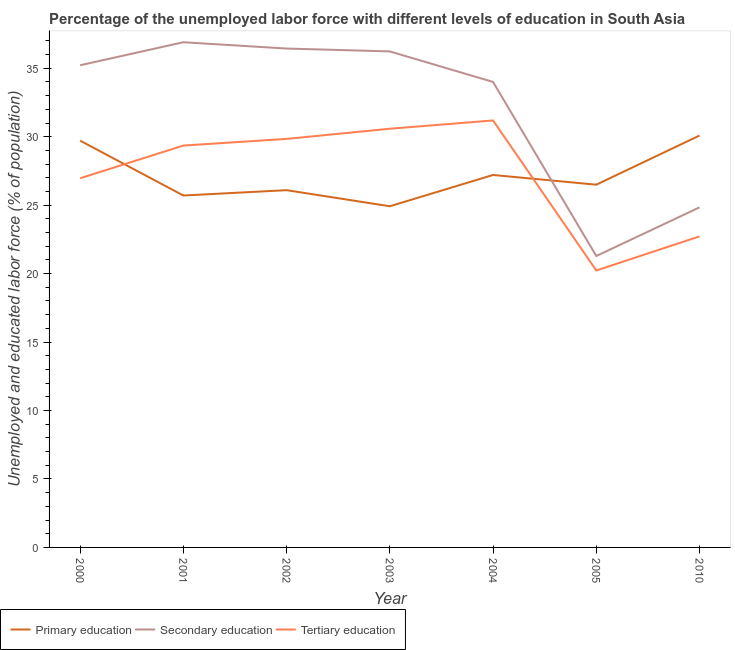How many different coloured lines are there?
Ensure brevity in your answer.  3. Does the line corresponding to percentage of labor force who received tertiary education intersect with the line corresponding to percentage of labor force who received secondary education?
Provide a succinct answer. No. Is the number of lines equal to the number of legend labels?
Your answer should be very brief. Yes. What is the percentage of labor force who received tertiary education in 2004?
Offer a very short reply. 31.19. Across all years, what is the maximum percentage of labor force who received primary education?
Your answer should be very brief. 30.08. Across all years, what is the minimum percentage of labor force who received tertiary education?
Your answer should be compact. 20.23. What is the total percentage of labor force who received secondary education in the graph?
Your answer should be very brief. 224.9. What is the difference between the percentage of labor force who received secondary education in 2000 and that in 2002?
Your response must be concise. -1.22. What is the difference between the percentage of labor force who received primary education in 2004 and the percentage of labor force who received tertiary education in 2001?
Ensure brevity in your answer.  -2.15. What is the average percentage of labor force who received primary education per year?
Offer a terse response. 27.17. In the year 2005, what is the difference between the percentage of labor force who received secondary education and percentage of labor force who received primary education?
Offer a very short reply. -5.21. In how many years, is the percentage of labor force who received primary education greater than 15 %?
Provide a short and direct response. 7. What is the ratio of the percentage of labor force who received secondary education in 2003 to that in 2005?
Offer a terse response. 1.7. What is the difference between the highest and the second highest percentage of labor force who received secondary education?
Make the answer very short. 0.46. What is the difference between the highest and the lowest percentage of labor force who received tertiary education?
Keep it short and to the point. 10.96. Is the sum of the percentage of labor force who received primary education in 2000 and 2010 greater than the maximum percentage of labor force who received secondary education across all years?
Provide a succinct answer. Yes. Is it the case that in every year, the sum of the percentage of labor force who received primary education and percentage of labor force who received secondary education is greater than the percentage of labor force who received tertiary education?
Give a very brief answer. Yes. How many lines are there?
Provide a succinct answer. 3. How many years are there in the graph?
Your answer should be compact. 7. Are the values on the major ticks of Y-axis written in scientific E-notation?
Your response must be concise. No. Does the graph contain any zero values?
Offer a terse response. No. Does the graph contain grids?
Your answer should be compact. No. Where does the legend appear in the graph?
Ensure brevity in your answer.  Bottom left. What is the title of the graph?
Keep it short and to the point. Percentage of the unemployed labor force with different levels of education in South Asia. Does "Male employers" appear as one of the legend labels in the graph?
Your answer should be very brief. No. What is the label or title of the X-axis?
Your response must be concise. Year. What is the label or title of the Y-axis?
Your answer should be compact. Unemployed and educated labor force (% of population). What is the Unemployed and educated labor force (% of population) in Primary education in 2000?
Give a very brief answer. 29.71. What is the Unemployed and educated labor force (% of population) in Secondary education in 2000?
Provide a short and direct response. 35.22. What is the Unemployed and educated labor force (% of population) in Tertiary education in 2000?
Your answer should be very brief. 26.96. What is the Unemployed and educated labor force (% of population) of Primary education in 2001?
Your answer should be compact. 25.7. What is the Unemployed and educated labor force (% of population) in Secondary education in 2001?
Offer a terse response. 36.9. What is the Unemployed and educated labor force (% of population) of Tertiary education in 2001?
Make the answer very short. 29.35. What is the Unemployed and educated labor force (% of population) in Primary education in 2002?
Provide a succinct answer. 26.09. What is the Unemployed and educated labor force (% of population) in Secondary education in 2002?
Keep it short and to the point. 36.44. What is the Unemployed and educated labor force (% of population) in Tertiary education in 2002?
Your answer should be compact. 29.84. What is the Unemployed and educated labor force (% of population) in Primary education in 2003?
Your answer should be very brief. 24.92. What is the Unemployed and educated labor force (% of population) of Secondary education in 2003?
Offer a terse response. 36.23. What is the Unemployed and educated labor force (% of population) in Tertiary education in 2003?
Provide a short and direct response. 30.58. What is the Unemployed and educated labor force (% of population) in Primary education in 2004?
Your answer should be very brief. 27.2. What is the Unemployed and educated labor force (% of population) of Secondary education in 2004?
Make the answer very short. 34. What is the Unemployed and educated labor force (% of population) of Tertiary education in 2004?
Offer a terse response. 31.19. What is the Unemployed and educated labor force (% of population) of Primary education in 2005?
Your response must be concise. 26.5. What is the Unemployed and educated labor force (% of population) of Secondary education in 2005?
Give a very brief answer. 21.28. What is the Unemployed and educated labor force (% of population) of Tertiary education in 2005?
Make the answer very short. 20.23. What is the Unemployed and educated labor force (% of population) in Primary education in 2010?
Provide a short and direct response. 30.08. What is the Unemployed and educated labor force (% of population) of Secondary education in 2010?
Provide a short and direct response. 24.84. What is the Unemployed and educated labor force (% of population) of Tertiary education in 2010?
Your answer should be very brief. 22.72. Across all years, what is the maximum Unemployed and educated labor force (% of population) of Primary education?
Keep it short and to the point. 30.08. Across all years, what is the maximum Unemployed and educated labor force (% of population) in Secondary education?
Give a very brief answer. 36.9. Across all years, what is the maximum Unemployed and educated labor force (% of population) of Tertiary education?
Your response must be concise. 31.19. Across all years, what is the minimum Unemployed and educated labor force (% of population) in Primary education?
Ensure brevity in your answer.  24.92. Across all years, what is the minimum Unemployed and educated labor force (% of population) in Secondary education?
Offer a terse response. 21.28. Across all years, what is the minimum Unemployed and educated labor force (% of population) of Tertiary education?
Give a very brief answer. 20.23. What is the total Unemployed and educated labor force (% of population) in Primary education in the graph?
Offer a very short reply. 190.21. What is the total Unemployed and educated labor force (% of population) in Secondary education in the graph?
Your answer should be compact. 224.9. What is the total Unemployed and educated labor force (% of population) in Tertiary education in the graph?
Provide a succinct answer. 190.87. What is the difference between the Unemployed and educated labor force (% of population) in Primary education in 2000 and that in 2001?
Provide a short and direct response. 4.01. What is the difference between the Unemployed and educated labor force (% of population) of Secondary education in 2000 and that in 2001?
Your answer should be compact. -1.68. What is the difference between the Unemployed and educated labor force (% of population) of Tertiary education in 2000 and that in 2001?
Your response must be concise. -2.39. What is the difference between the Unemployed and educated labor force (% of population) of Primary education in 2000 and that in 2002?
Ensure brevity in your answer.  3.62. What is the difference between the Unemployed and educated labor force (% of population) of Secondary education in 2000 and that in 2002?
Give a very brief answer. -1.22. What is the difference between the Unemployed and educated labor force (% of population) in Tertiary education in 2000 and that in 2002?
Your answer should be very brief. -2.88. What is the difference between the Unemployed and educated labor force (% of population) in Primary education in 2000 and that in 2003?
Offer a terse response. 4.79. What is the difference between the Unemployed and educated labor force (% of population) of Secondary education in 2000 and that in 2003?
Give a very brief answer. -1.01. What is the difference between the Unemployed and educated labor force (% of population) in Tertiary education in 2000 and that in 2003?
Offer a terse response. -3.62. What is the difference between the Unemployed and educated labor force (% of population) in Primary education in 2000 and that in 2004?
Your answer should be compact. 2.51. What is the difference between the Unemployed and educated labor force (% of population) in Secondary education in 2000 and that in 2004?
Keep it short and to the point. 1.22. What is the difference between the Unemployed and educated labor force (% of population) of Tertiary education in 2000 and that in 2004?
Offer a terse response. -4.22. What is the difference between the Unemployed and educated labor force (% of population) in Primary education in 2000 and that in 2005?
Give a very brief answer. 3.22. What is the difference between the Unemployed and educated labor force (% of population) of Secondary education in 2000 and that in 2005?
Make the answer very short. 13.93. What is the difference between the Unemployed and educated labor force (% of population) in Tertiary education in 2000 and that in 2005?
Keep it short and to the point. 6.74. What is the difference between the Unemployed and educated labor force (% of population) in Primary education in 2000 and that in 2010?
Your response must be concise. -0.37. What is the difference between the Unemployed and educated labor force (% of population) of Secondary education in 2000 and that in 2010?
Keep it short and to the point. 10.38. What is the difference between the Unemployed and educated labor force (% of population) in Tertiary education in 2000 and that in 2010?
Your answer should be very brief. 4.24. What is the difference between the Unemployed and educated labor force (% of population) of Primary education in 2001 and that in 2002?
Offer a very short reply. -0.39. What is the difference between the Unemployed and educated labor force (% of population) in Secondary education in 2001 and that in 2002?
Make the answer very short. 0.46. What is the difference between the Unemployed and educated labor force (% of population) in Tertiary education in 2001 and that in 2002?
Provide a short and direct response. -0.49. What is the difference between the Unemployed and educated labor force (% of population) in Primary education in 2001 and that in 2003?
Offer a very short reply. 0.78. What is the difference between the Unemployed and educated labor force (% of population) of Secondary education in 2001 and that in 2003?
Provide a short and direct response. 0.67. What is the difference between the Unemployed and educated labor force (% of population) in Tertiary education in 2001 and that in 2003?
Provide a succinct answer. -1.23. What is the difference between the Unemployed and educated labor force (% of population) in Primary education in 2001 and that in 2004?
Give a very brief answer. -1.5. What is the difference between the Unemployed and educated labor force (% of population) in Secondary education in 2001 and that in 2004?
Your answer should be compact. 2.9. What is the difference between the Unemployed and educated labor force (% of population) of Tertiary education in 2001 and that in 2004?
Provide a short and direct response. -1.83. What is the difference between the Unemployed and educated labor force (% of population) of Primary education in 2001 and that in 2005?
Keep it short and to the point. -0.79. What is the difference between the Unemployed and educated labor force (% of population) in Secondary education in 2001 and that in 2005?
Provide a succinct answer. 15.61. What is the difference between the Unemployed and educated labor force (% of population) in Tertiary education in 2001 and that in 2005?
Provide a succinct answer. 9.12. What is the difference between the Unemployed and educated labor force (% of population) in Primary education in 2001 and that in 2010?
Provide a short and direct response. -4.38. What is the difference between the Unemployed and educated labor force (% of population) in Secondary education in 2001 and that in 2010?
Provide a short and direct response. 12.06. What is the difference between the Unemployed and educated labor force (% of population) in Tertiary education in 2001 and that in 2010?
Ensure brevity in your answer.  6.63. What is the difference between the Unemployed and educated labor force (% of population) of Primary education in 2002 and that in 2003?
Provide a short and direct response. 1.17. What is the difference between the Unemployed and educated labor force (% of population) in Secondary education in 2002 and that in 2003?
Offer a terse response. 0.21. What is the difference between the Unemployed and educated labor force (% of population) of Tertiary education in 2002 and that in 2003?
Offer a terse response. -0.74. What is the difference between the Unemployed and educated labor force (% of population) of Primary education in 2002 and that in 2004?
Offer a terse response. -1.11. What is the difference between the Unemployed and educated labor force (% of population) of Secondary education in 2002 and that in 2004?
Provide a succinct answer. 2.44. What is the difference between the Unemployed and educated labor force (% of population) in Tertiary education in 2002 and that in 2004?
Provide a short and direct response. -1.35. What is the difference between the Unemployed and educated labor force (% of population) in Primary education in 2002 and that in 2005?
Provide a short and direct response. -0.4. What is the difference between the Unemployed and educated labor force (% of population) in Secondary education in 2002 and that in 2005?
Your response must be concise. 15.15. What is the difference between the Unemployed and educated labor force (% of population) in Tertiary education in 2002 and that in 2005?
Make the answer very short. 9.61. What is the difference between the Unemployed and educated labor force (% of population) in Primary education in 2002 and that in 2010?
Your answer should be very brief. -3.99. What is the difference between the Unemployed and educated labor force (% of population) of Secondary education in 2002 and that in 2010?
Provide a short and direct response. 11.6. What is the difference between the Unemployed and educated labor force (% of population) in Tertiary education in 2002 and that in 2010?
Give a very brief answer. 7.12. What is the difference between the Unemployed and educated labor force (% of population) of Primary education in 2003 and that in 2004?
Your answer should be compact. -2.28. What is the difference between the Unemployed and educated labor force (% of population) of Secondary education in 2003 and that in 2004?
Keep it short and to the point. 2.23. What is the difference between the Unemployed and educated labor force (% of population) in Tertiary education in 2003 and that in 2004?
Ensure brevity in your answer.  -0.61. What is the difference between the Unemployed and educated labor force (% of population) of Primary education in 2003 and that in 2005?
Provide a succinct answer. -1.58. What is the difference between the Unemployed and educated labor force (% of population) in Secondary education in 2003 and that in 2005?
Offer a very short reply. 14.94. What is the difference between the Unemployed and educated labor force (% of population) in Tertiary education in 2003 and that in 2005?
Your response must be concise. 10.35. What is the difference between the Unemployed and educated labor force (% of population) in Primary education in 2003 and that in 2010?
Offer a terse response. -5.17. What is the difference between the Unemployed and educated labor force (% of population) in Secondary education in 2003 and that in 2010?
Offer a very short reply. 11.39. What is the difference between the Unemployed and educated labor force (% of population) of Tertiary education in 2003 and that in 2010?
Make the answer very short. 7.86. What is the difference between the Unemployed and educated labor force (% of population) in Primary education in 2004 and that in 2005?
Ensure brevity in your answer.  0.71. What is the difference between the Unemployed and educated labor force (% of population) in Secondary education in 2004 and that in 2005?
Offer a terse response. 12.71. What is the difference between the Unemployed and educated labor force (% of population) in Tertiary education in 2004 and that in 2005?
Provide a succinct answer. 10.96. What is the difference between the Unemployed and educated labor force (% of population) in Primary education in 2004 and that in 2010?
Provide a succinct answer. -2.88. What is the difference between the Unemployed and educated labor force (% of population) in Secondary education in 2004 and that in 2010?
Ensure brevity in your answer.  9.16. What is the difference between the Unemployed and educated labor force (% of population) in Tertiary education in 2004 and that in 2010?
Your response must be concise. 8.47. What is the difference between the Unemployed and educated labor force (% of population) in Primary education in 2005 and that in 2010?
Your answer should be very brief. -3.59. What is the difference between the Unemployed and educated labor force (% of population) of Secondary education in 2005 and that in 2010?
Offer a very short reply. -3.55. What is the difference between the Unemployed and educated labor force (% of population) of Tertiary education in 2005 and that in 2010?
Your answer should be very brief. -2.49. What is the difference between the Unemployed and educated labor force (% of population) in Primary education in 2000 and the Unemployed and educated labor force (% of population) in Secondary education in 2001?
Ensure brevity in your answer.  -7.19. What is the difference between the Unemployed and educated labor force (% of population) of Primary education in 2000 and the Unemployed and educated labor force (% of population) of Tertiary education in 2001?
Offer a very short reply. 0.36. What is the difference between the Unemployed and educated labor force (% of population) in Secondary education in 2000 and the Unemployed and educated labor force (% of population) in Tertiary education in 2001?
Give a very brief answer. 5.87. What is the difference between the Unemployed and educated labor force (% of population) of Primary education in 2000 and the Unemployed and educated labor force (% of population) of Secondary education in 2002?
Provide a short and direct response. -6.73. What is the difference between the Unemployed and educated labor force (% of population) in Primary education in 2000 and the Unemployed and educated labor force (% of population) in Tertiary education in 2002?
Keep it short and to the point. -0.13. What is the difference between the Unemployed and educated labor force (% of population) in Secondary education in 2000 and the Unemployed and educated labor force (% of population) in Tertiary education in 2002?
Ensure brevity in your answer.  5.38. What is the difference between the Unemployed and educated labor force (% of population) in Primary education in 2000 and the Unemployed and educated labor force (% of population) in Secondary education in 2003?
Keep it short and to the point. -6.52. What is the difference between the Unemployed and educated labor force (% of population) in Primary education in 2000 and the Unemployed and educated labor force (% of population) in Tertiary education in 2003?
Offer a very short reply. -0.87. What is the difference between the Unemployed and educated labor force (% of population) of Secondary education in 2000 and the Unemployed and educated labor force (% of population) of Tertiary education in 2003?
Make the answer very short. 4.64. What is the difference between the Unemployed and educated labor force (% of population) of Primary education in 2000 and the Unemployed and educated labor force (% of population) of Secondary education in 2004?
Offer a terse response. -4.29. What is the difference between the Unemployed and educated labor force (% of population) in Primary education in 2000 and the Unemployed and educated labor force (% of population) in Tertiary education in 2004?
Give a very brief answer. -1.47. What is the difference between the Unemployed and educated labor force (% of population) in Secondary education in 2000 and the Unemployed and educated labor force (% of population) in Tertiary education in 2004?
Your answer should be compact. 4.03. What is the difference between the Unemployed and educated labor force (% of population) in Primary education in 2000 and the Unemployed and educated labor force (% of population) in Secondary education in 2005?
Provide a short and direct response. 8.43. What is the difference between the Unemployed and educated labor force (% of population) of Primary education in 2000 and the Unemployed and educated labor force (% of population) of Tertiary education in 2005?
Offer a very short reply. 9.48. What is the difference between the Unemployed and educated labor force (% of population) in Secondary education in 2000 and the Unemployed and educated labor force (% of population) in Tertiary education in 2005?
Give a very brief answer. 14.99. What is the difference between the Unemployed and educated labor force (% of population) in Primary education in 2000 and the Unemployed and educated labor force (% of population) in Secondary education in 2010?
Your answer should be compact. 4.87. What is the difference between the Unemployed and educated labor force (% of population) of Primary education in 2000 and the Unemployed and educated labor force (% of population) of Tertiary education in 2010?
Keep it short and to the point. 6.99. What is the difference between the Unemployed and educated labor force (% of population) in Secondary education in 2000 and the Unemployed and educated labor force (% of population) in Tertiary education in 2010?
Give a very brief answer. 12.5. What is the difference between the Unemployed and educated labor force (% of population) in Primary education in 2001 and the Unemployed and educated labor force (% of population) in Secondary education in 2002?
Your answer should be compact. -10.73. What is the difference between the Unemployed and educated labor force (% of population) in Primary education in 2001 and the Unemployed and educated labor force (% of population) in Tertiary education in 2002?
Ensure brevity in your answer.  -4.14. What is the difference between the Unemployed and educated labor force (% of population) in Secondary education in 2001 and the Unemployed and educated labor force (% of population) in Tertiary education in 2002?
Ensure brevity in your answer.  7.06. What is the difference between the Unemployed and educated labor force (% of population) of Primary education in 2001 and the Unemployed and educated labor force (% of population) of Secondary education in 2003?
Keep it short and to the point. -10.53. What is the difference between the Unemployed and educated labor force (% of population) in Primary education in 2001 and the Unemployed and educated labor force (% of population) in Tertiary education in 2003?
Provide a short and direct response. -4.88. What is the difference between the Unemployed and educated labor force (% of population) in Secondary education in 2001 and the Unemployed and educated labor force (% of population) in Tertiary education in 2003?
Your response must be concise. 6.32. What is the difference between the Unemployed and educated labor force (% of population) in Primary education in 2001 and the Unemployed and educated labor force (% of population) in Secondary education in 2004?
Offer a very short reply. -8.3. What is the difference between the Unemployed and educated labor force (% of population) of Primary education in 2001 and the Unemployed and educated labor force (% of population) of Tertiary education in 2004?
Make the answer very short. -5.48. What is the difference between the Unemployed and educated labor force (% of population) in Secondary education in 2001 and the Unemployed and educated labor force (% of population) in Tertiary education in 2004?
Offer a very short reply. 5.71. What is the difference between the Unemployed and educated labor force (% of population) in Primary education in 2001 and the Unemployed and educated labor force (% of population) in Secondary education in 2005?
Offer a terse response. 4.42. What is the difference between the Unemployed and educated labor force (% of population) of Primary education in 2001 and the Unemployed and educated labor force (% of population) of Tertiary education in 2005?
Provide a succinct answer. 5.48. What is the difference between the Unemployed and educated labor force (% of population) of Secondary education in 2001 and the Unemployed and educated labor force (% of population) of Tertiary education in 2005?
Your response must be concise. 16.67. What is the difference between the Unemployed and educated labor force (% of population) of Primary education in 2001 and the Unemployed and educated labor force (% of population) of Secondary education in 2010?
Make the answer very short. 0.86. What is the difference between the Unemployed and educated labor force (% of population) of Primary education in 2001 and the Unemployed and educated labor force (% of population) of Tertiary education in 2010?
Give a very brief answer. 2.98. What is the difference between the Unemployed and educated labor force (% of population) in Secondary education in 2001 and the Unemployed and educated labor force (% of population) in Tertiary education in 2010?
Provide a short and direct response. 14.18. What is the difference between the Unemployed and educated labor force (% of population) in Primary education in 2002 and the Unemployed and educated labor force (% of population) in Secondary education in 2003?
Ensure brevity in your answer.  -10.14. What is the difference between the Unemployed and educated labor force (% of population) in Primary education in 2002 and the Unemployed and educated labor force (% of population) in Tertiary education in 2003?
Make the answer very short. -4.49. What is the difference between the Unemployed and educated labor force (% of population) of Secondary education in 2002 and the Unemployed and educated labor force (% of population) of Tertiary education in 2003?
Your response must be concise. 5.86. What is the difference between the Unemployed and educated labor force (% of population) of Primary education in 2002 and the Unemployed and educated labor force (% of population) of Secondary education in 2004?
Provide a succinct answer. -7.9. What is the difference between the Unemployed and educated labor force (% of population) in Primary education in 2002 and the Unemployed and educated labor force (% of population) in Tertiary education in 2004?
Your answer should be compact. -5.09. What is the difference between the Unemployed and educated labor force (% of population) of Secondary education in 2002 and the Unemployed and educated labor force (% of population) of Tertiary education in 2004?
Offer a terse response. 5.25. What is the difference between the Unemployed and educated labor force (% of population) in Primary education in 2002 and the Unemployed and educated labor force (% of population) in Secondary education in 2005?
Your answer should be very brief. 4.81. What is the difference between the Unemployed and educated labor force (% of population) in Primary education in 2002 and the Unemployed and educated labor force (% of population) in Tertiary education in 2005?
Your answer should be compact. 5.87. What is the difference between the Unemployed and educated labor force (% of population) of Secondary education in 2002 and the Unemployed and educated labor force (% of population) of Tertiary education in 2005?
Your answer should be very brief. 16.21. What is the difference between the Unemployed and educated labor force (% of population) in Primary education in 2002 and the Unemployed and educated labor force (% of population) in Secondary education in 2010?
Provide a succinct answer. 1.26. What is the difference between the Unemployed and educated labor force (% of population) in Primary education in 2002 and the Unemployed and educated labor force (% of population) in Tertiary education in 2010?
Offer a terse response. 3.37. What is the difference between the Unemployed and educated labor force (% of population) in Secondary education in 2002 and the Unemployed and educated labor force (% of population) in Tertiary education in 2010?
Your answer should be very brief. 13.72. What is the difference between the Unemployed and educated labor force (% of population) in Primary education in 2003 and the Unemployed and educated labor force (% of population) in Secondary education in 2004?
Provide a short and direct response. -9.08. What is the difference between the Unemployed and educated labor force (% of population) in Primary education in 2003 and the Unemployed and educated labor force (% of population) in Tertiary education in 2004?
Your answer should be very brief. -6.27. What is the difference between the Unemployed and educated labor force (% of population) in Secondary education in 2003 and the Unemployed and educated labor force (% of population) in Tertiary education in 2004?
Ensure brevity in your answer.  5.04. What is the difference between the Unemployed and educated labor force (% of population) in Primary education in 2003 and the Unemployed and educated labor force (% of population) in Secondary education in 2005?
Keep it short and to the point. 3.63. What is the difference between the Unemployed and educated labor force (% of population) in Primary education in 2003 and the Unemployed and educated labor force (% of population) in Tertiary education in 2005?
Give a very brief answer. 4.69. What is the difference between the Unemployed and educated labor force (% of population) in Secondary education in 2003 and the Unemployed and educated labor force (% of population) in Tertiary education in 2005?
Keep it short and to the point. 16. What is the difference between the Unemployed and educated labor force (% of population) of Primary education in 2003 and the Unemployed and educated labor force (% of population) of Secondary education in 2010?
Provide a succinct answer. 0.08. What is the difference between the Unemployed and educated labor force (% of population) in Primary education in 2003 and the Unemployed and educated labor force (% of population) in Tertiary education in 2010?
Provide a succinct answer. 2.2. What is the difference between the Unemployed and educated labor force (% of population) of Secondary education in 2003 and the Unemployed and educated labor force (% of population) of Tertiary education in 2010?
Provide a short and direct response. 13.51. What is the difference between the Unemployed and educated labor force (% of population) in Primary education in 2004 and the Unemployed and educated labor force (% of population) in Secondary education in 2005?
Give a very brief answer. 5.92. What is the difference between the Unemployed and educated labor force (% of population) in Primary education in 2004 and the Unemployed and educated labor force (% of population) in Tertiary education in 2005?
Make the answer very short. 6.98. What is the difference between the Unemployed and educated labor force (% of population) in Secondary education in 2004 and the Unemployed and educated labor force (% of population) in Tertiary education in 2005?
Offer a terse response. 13.77. What is the difference between the Unemployed and educated labor force (% of population) of Primary education in 2004 and the Unemployed and educated labor force (% of population) of Secondary education in 2010?
Offer a very short reply. 2.37. What is the difference between the Unemployed and educated labor force (% of population) in Primary education in 2004 and the Unemployed and educated labor force (% of population) in Tertiary education in 2010?
Keep it short and to the point. 4.48. What is the difference between the Unemployed and educated labor force (% of population) of Secondary education in 2004 and the Unemployed and educated labor force (% of population) of Tertiary education in 2010?
Provide a short and direct response. 11.28. What is the difference between the Unemployed and educated labor force (% of population) in Primary education in 2005 and the Unemployed and educated labor force (% of population) in Secondary education in 2010?
Ensure brevity in your answer.  1.66. What is the difference between the Unemployed and educated labor force (% of population) of Primary education in 2005 and the Unemployed and educated labor force (% of population) of Tertiary education in 2010?
Your response must be concise. 3.78. What is the difference between the Unemployed and educated labor force (% of population) of Secondary education in 2005 and the Unemployed and educated labor force (% of population) of Tertiary education in 2010?
Your answer should be very brief. -1.43. What is the average Unemployed and educated labor force (% of population) of Primary education per year?
Provide a succinct answer. 27.17. What is the average Unemployed and educated labor force (% of population) in Secondary education per year?
Offer a terse response. 32.13. What is the average Unemployed and educated labor force (% of population) of Tertiary education per year?
Your answer should be very brief. 27.27. In the year 2000, what is the difference between the Unemployed and educated labor force (% of population) of Primary education and Unemployed and educated labor force (% of population) of Secondary education?
Provide a short and direct response. -5.51. In the year 2000, what is the difference between the Unemployed and educated labor force (% of population) in Primary education and Unemployed and educated labor force (% of population) in Tertiary education?
Your response must be concise. 2.75. In the year 2000, what is the difference between the Unemployed and educated labor force (% of population) of Secondary education and Unemployed and educated labor force (% of population) of Tertiary education?
Provide a succinct answer. 8.25. In the year 2001, what is the difference between the Unemployed and educated labor force (% of population) of Primary education and Unemployed and educated labor force (% of population) of Secondary education?
Your answer should be compact. -11.2. In the year 2001, what is the difference between the Unemployed and educated labor force (% of population) of Primary education and Unemployed and educated labor force (% of population) of Tertiary education?
Your answer should be very brief. -3.65. In the year 2001, what is the difference between the Unemployed and educated labor force (% of population) of Secondary education and Unemployed and educated labor force (% of population) of Tertiary education?
Offer a very short reply. 7.55. In the year 2002, what is the difference between the Unemployed and educated labor force (% of population) of Primary education and Unemployed and educated labor force (% of population) of Secondary education?
Make the answer very short. -10.34. In the year 2002, what is the difference between the Unemployed and educated labor force (% of population) of Primary education and Unemployed and educated labor force (% of population) of Tertiary education?
Offer a terse response. -3.75. In the year 2002, what is the difference between the Unemployed and educated labor force (% of population) in Secondary education and Unemployed and educated labor force (% of population) in Tertiary education?
Ensure brevity in your answer.  6.6. In the year 2003, what is the difference between the Unemployed and educated labor force (% of population) in Primary education and Unemployed and educated labor force (% of population) in Secondary education?
Your response must be concise. -11.31. In the year 2003, what is the difference between the Unemployed and educated labor force (% of population) of Primary education and Unemployed and educated labor force (% of population) of Tertiary education?
Give a very brief answer. -5.66. In the year 2003, what is the difference between the Unemployed and educated labor force (% of population) of Secondary education and Unemployed and educated labor force (% of population) of Tertiary education?
Provide a short and direct response. 5.65. In the year 2004, what is the difference between the Unemployed and educated labor force (% of population) in Primary education and Unemployed and educated labor force (% of population) in Secondary education?
Provide a short and direct response. -6.79. In the year 2004, what is the difference between the Unemployed and educated labor force (% of population) in Primary education and Unemployed and educated labor force (% of population) in Tertiary education?
Make the answer very short. -3.98. In the year 2004, what is the difference between the Unemployed and educated labor force (% of population) of Secondary education and Unemployed and educated labor force (% of population) of Tertiary education?
Your answer should be very brief. 2.81. In the year 2005, what is the difference between the Unemployed and educated labor force (% of population) in Primary education and Unemployed and educated labor force (% of population) in Secondary education?
Your answer should be compact. 5.21. In the year 2005, what is the difference between the Unemployed and educated labor force (% of population) of Primary education and Unemployed and educated labor force (% of population) of Tertiary education?
Ensure brevity in your answer.  6.27. In the year 2005, what is the difference between the Unemployed and educated labor force (% of population) in Secondary education and Unemployed and educated labor force (% of population) in Tertiary education?
Provide a short and direct response. 1.06. In the year 2010, what is the difference between the Unemployed and educated labor force (% of population) of Primary education and Unemployed and educated labor force (% of population) of Secondary education?
Your response must be concise. 5.25. In the year 2010, what is the difference between the Unemployed and educated labor force (% of population) of Primary education and Unemployed and educated labor force (% of population) of Tertiary education?
Provide a short and direct response. 7.37. In the year 2010, what is the difference between the Unemployed and educated labor force (% of population) of Secondary education and Unemployed and educated labor force (% of population) of Tertiary education?
Provide a succinct answer. 2.12. What is the ratio of the Unemployed and educated labor force (% of population) of Primary education in 2000 to that in 2001?
Your response must be concise. 1.16. What is the ratio of the Unemployed and educated labor force (% of population) in Secondary education in 2000 to that in 2001?
Give a very brief answer. 0.95. What is the ratio of the Unemployed and educated labor force (% of population) of Tertiary education in 2000 to that in 2001?
Ensure brevity in your answer.  0.92. What is the ratio of the Unemployed and educated labor force (% of population) in Primary education in 2000 to that in 2002?
Make the answer very short. 1.14. What is the ratio of the Unemployed and educated labor force (% of population) in Secondary education in 2000 to that in 2002?
Your answer should be compact. 0.97. What is the ratio of the Unemployed and educated labor force (% of population) in Tertiary education in 2000 to that in 2002?
Your answer should be compact. 0.9. What is the ratio of the Unemployed and educated labor force (% of population) in Primary education in 2000 to that in 2003?
Your answer should be compact. 1.19. What is the ratio of the Unemployed and educated labor force (% of population) in Secondary education in 2000 to that in 2003?
Offer a very short reply. 0.97. What is the ratio of the Unemployed and educated labor force (% of population) in Tertiary education in 2000 to that in 2003?
Offer a terse response. 0.88. What is the ratio of the Unemployed and educated labor force (% of population) of Primary education in 2000 to that in 2004?
Provide a short and direct response. 1.09. What is the ratio of the Unemployed and educated labor force (% of population) in Secondary education in 2000 to that in 2004?
Your answer should be compact. 1.04. What is the ratio of the Unemployed and educated labor force (% of population) in Tertiary education in 2000 to that in 2004?
Your answer should be very brief. 0.86. What is the ratio of the Unemployed and educated labor force (% of population) in Primary education in 2000 to that in 2005?
Your answer should be compact. 1.12. What is the ratio of the Unemployed and educated labor force (% of population) of Secondary education in 2000 to that in 2005?
Your answer should be very brief. 1.65. What is the ratio of the Unemployed and educated labor force (% of population) of Tertiary education in 2000 to that in 2005?
Your response must be concise. 1.33. What is the ratio of the Unemployed and educated labor force (% of population) in Primary education in 2000 to that in 2010?
Give a very brief answer. 0.99. What is the ratio of the Unemployed and educated labor force (% of population) of Secondary education in 2000 to that in 2010?
Your response must be concise. 1.42. What is the ratio of the Unemployed and educated labor force (% of population) of Tertiary education in 2000 to that in 2010?
Give a very brief answer. 1.19. What is the ratio of the Unemployed and educated labor force (% of population) in Secondary education in 2001 to that in 2002?
Offer a very short reply. 1.01. What is the ratio of the Unemployed and educated labor force (% of population) in Tertiary education in 2001 to that in 2002?
Your response must be concise. 0.98. What is the ratio of the Unemployed and educated labor force (% of population) in Primary education in 2001 to that in 2003?
Offer a very short reply. 1.03. What is the ratio of the Unemployed and educated labor force (% of population) in Secondary education in 2001 to that in 2003?
Your answer should be very brief. 1.02. What is the ratio of the Unemployed and educated labor force (% of population) in Tertiary education in 2001 to that in 2003?
Your answer should be very brief. 0.96. What is the ratio of the Unemployed and educated labor force (% of population) in Primary education in 2001 to that in 2004?
Keep it short and to the point. 0.94. What is the ratio of the Unemployed and educated labor force (% of population) of Secondary education in 2001 to that in 2004?
Make the answer very short. 1.09. What is the ratio of the Unemployed and educated labor force (% of population) of Primary education in 2001 to that in 2005?
Keep it short and to the point. 0.97. What is the ratio of the Unemployed and educated labor force (% of population) in Secondary education in 2001 to that in 2005?
Ensure brevity in your answer.  1.73. What is the ratio of the Unemployed and educated labor force (% of population) of Tertiary education in 2001 to that in 2005?
Offer a terse response. 1.45. What is the ratio of the Unemployed and educated labor force (% of population) of Primary education in 2001 to that in 2010?
Your answer should be very brief. 0.85. What is the ratio of the Unemployed and educated labor force (% of population) of Secondary education in 2001 to that in 2010?
Give a very brief answer. 1.49. What is the ratio of the Unemployed and educated labor force (% of population) in Tertiary education in 2001 to that in 2010?
Keep it short and to the point. 1.29. What is the ratio of the Unemployed and educated labor force (% of population) of Primary education in 2002 to that in 2003?
Your answer should be very brief. 1.05. What is the ratio of the Unemployed and educated labor force (% of population) in Tertiary education in 2002 to that in 2003?
Give a very brief answer. 0.98. What is the ratio of the Unemployed and educated labor force (% of population) of Primary education in 2002 to that in 2004?
Make the answer very short. 0.96. What is the ratio of the Unemployed and educated labor force (% of population) in Secondary education in 2002 to that in 2004?
Provide a succinct answer. 1.07. What is the ratio of the Unemployed and educated labor force (% of population) in Tertiary education in 2002 to that in 2004?
Offer a very short reply. 0.96. What is the ratio of the Unemployed and educated labor force (% of population) in Primary education in 2002 to that in 2005?
Your answer should be very brief. 0.98. What is the ratio of the Unemployed and educated labor force (% of population) of Secondary education in 2002 to that in 2005?
Your response must be concise. 1.71. What is the ratio of the Unemployed and educated labor force (% of population) in Tertiary education in 2002 to that in 2005?
Give a very brief answer. 1.48. What is the ratio of the Unemployed and educated labor force (% of population) of Primary education in 2002 to that in 2010?
Keep it short and to the point. 0.87. What is the ratio of the Unemployed and educated labor force (% of population) in Secondary education in 2002 to that in 2010?
Offer a terse response. 1.47. What is the ratio of the Unemployed and educated labor force (% of population) of Tertiary education in 2002 to that in 2010?
Offer a terse response. 1.31. What is the ratio of the Unemployed and educated labor force (% of population) in Primary education in 2003 to that in 2004?
Provide a short and direct response. 0.92. What is the ratio of the Unemployed and educated labor force (% of population) of Secondary education in 2003 to that in 2004?
Your response must be concise. 1.07. What is the ratio of the Unemployed and educated labor force (% of population) of Tertiary education in 2003 to that in 2004?
Offer a very short reply. 0.98. What is the ratio of the Unemployed and educated labor force (% of population) of Primary education in 2003 to that in 2005?
Your answer should be very brief. 0.94. What is the ratio of the Unemployed and educated labor force (% of population) in Secondary education in 2003 to that in 2005?
Offer a very short reply. 1.7. What is the ratio of the Unemployed and educated labor force (% of population) of Tertiary education in 2003 to that in 2005?
Offer a terse response. 1.51. What is the ratio of the Unemployed and educated labor force (% of population) in Primary education in 2003 to that in 2010?
Offer a very short reply. 0.83. What is the ratio of the Unemployed and educated labor force (% of population) of Secondary education in 2003 to that in 2010?
Make the answer very short. 1.46. What is the ratio of the Unemployed and educated labor force (% of population) of Tertiary education in 2003 to that in 2010?
Offer a terse response. 1.35. What is the ratio of the Unemployed and educated labor force (% of population) of Primary education in 2004 to that in 2005?
Keep it short and to the point. 1.03. What is the ratio of the Unemployed and educated labor force (% of population) of Secondary education in 2004 to that in 2005?
Provide a short and direct response. 1.6. What is the ratio of the Unemployed and educated labor force (% of population) in Tertiary education in 2004 to that in 2005?
Provide a succinct answer. 1.54. What is the ratio of the Unemployed and educated labor force (% of population) in Primary education in 2004 to that in 2010?
Offer a terse response. 0.9. What is the ratio of the Unemployed and educated labor force (% of population) in Secondary education in 2004 to that in 2010?
Your response must be concise. 1.37. What is the ratio of the Unemployed and educated labor force (% of population) of Tertiary education in 2004 to that in 2010?
Your response must be concise. 1.37. What is the ratio of the Unemployed and educated labor force (% of population) of Primary education in 2005 to that in 2010?
Offer a terse response. 0.88. What is the ratio of the Unemployed and educated labor force (% of population) of Secondary education in 2005 to that in 2010?
Provide a succinct answer. 0.86. What is the ratio of the Unemployed and educated labor force (% of population) of Tertiary education in 2005 to that in 2010?
Offer a very short reply. 0.89. What is the difference between the highest and the second highest Unemployed and educated labor force (% of population) in Primary education?
Ensure brevity in your answer.  0.37. What is the difference between the highest and the second highest Unemployed and educated labor force (% of population) in Secondary education?
Make the answer very short. 0.46. What is the difference between the highest and the second highest Unemployed and educated labor force (% of population) of Tertiary education?
Give a very brief answer. 0.61. What is the difference between the highest and the lowest Unemployed and educated labor force (% of population) of Primary education?
Offer a very short reply. 5.17. What is the difference between the highest and the lowest Unemployed and educated labor force (% of population) in Secondary education?
Your answer should be very brief. 15.61. What is the difference between the highest and the lowest Unemployed and educated labor force (% of population) in Tertiary education?
Ensure brevity in your answer.  10.96. 